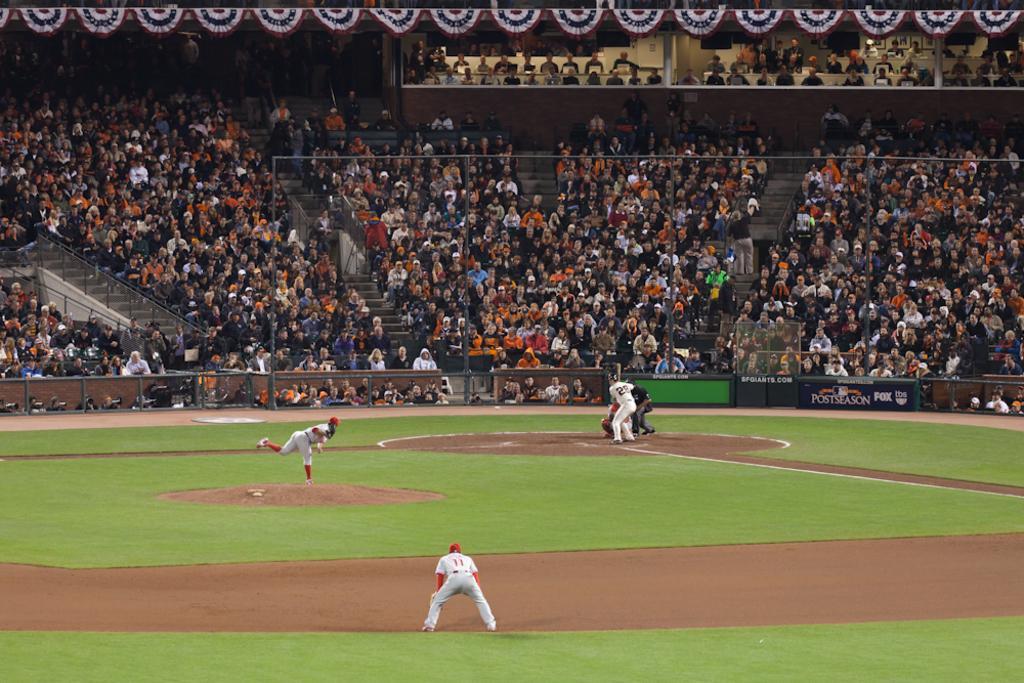Could you give a brief overview of what you see in this image? In this picture I can see a stadium, there are few people playing a game, there are boards, stairs, there are group of people and there are some objects. 